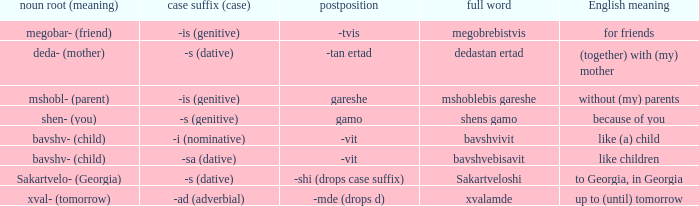What is the english definition when the case suffix (case) is "-sa (dative)"? Like children. 